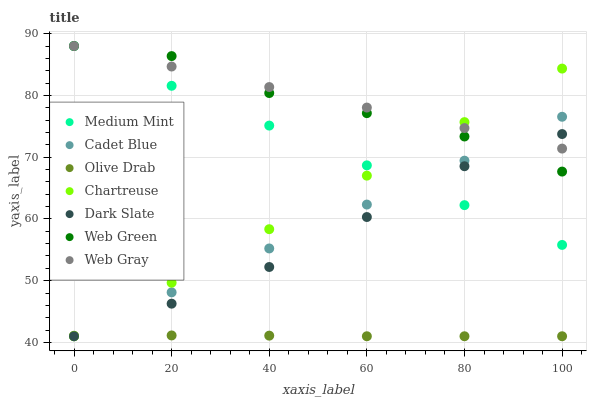Does Olive Drab have the minimum area under the curve?
Answer yes or no. Yes. Does Web Gray have the maximum area under the curve?
Answer yes or no. Yes. Does Cadet Blue have the minimum area under the curve?
Answer yes or no. No. Does Cadet Blue have the maximum area under the curve?
Answer yes or no. No. Is Web Gray the smoothest?
Answer yes or no. Yes. Is Web Green the roughest?
Answer yes or no. Yes. Is Cadet Blue the smoothest?
Answer yes or no. No. Is Cadet Blue the roughest?
Answer yes or no. No. Does Cadet Blue have the lowest value?
Answer yes or no. Yes. Does Web Green have the lowest value?
Answer yes or no. No. Does Web Gray have the highest value?
Answer yes or no. Yes. Does Cadet Blue have the highest value?
Answer yes or no. No. Is Olive Drab less than Web Gray?
Answer yes or no. Yes. Is Web Green greater than Olive Drab?
Answer yes or no. Yes. Does Olive Drab intersect Dark Slate?
Answer yes or no. Yes. Is Olive Drab less than Dark Slate?
Answer yes or no. No. Is Olive Drab greater than Dark Slate?
Answer yes or no. No. Does Olive Drab intersect Web Gray?
Answer yes or no. No. 